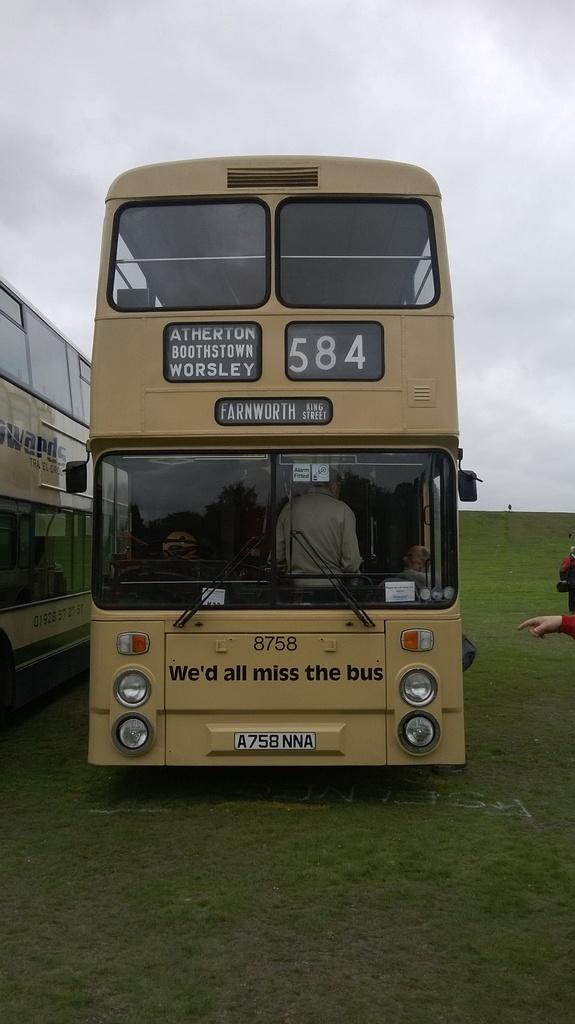What type of vehicles are in the image? There are buses in the image. Where are the buses located? The buses are on the grass. Can you describe the people visible in the image? Unfortunately, the facts provided do not give any information about the people in the image. What type of toothbrush is being used by the buses in the image? There is no toothbrush present in the image, as the main subjects are buses, not people or objects related to personal hygiene. 